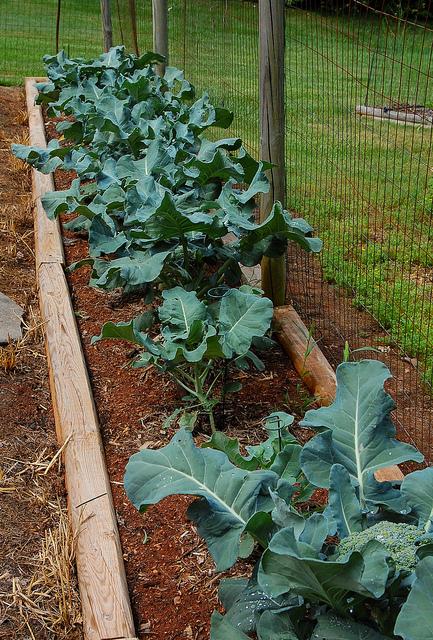Could that be poison ivy?
Answer briefly. No. How many red flowers?
Give a very brief answer. 0. What is the fence made out of?
Be succinct. Wire. How many sections in the garden?
Keep it brief. 1. Is this a garden?
Write a very short answer. Yes. 